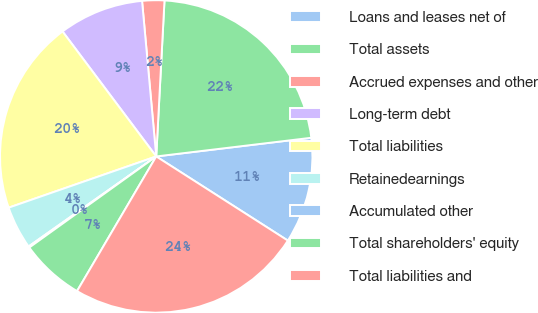Convert chart. <chart><loc_0><loc_0><loc_500><loc_500><pie_chart><fcel>Loans and leases net of<fcel>Total assets<fcel>Accrued expenses and other<fcel>Long-term debt<fcel>Total liabilities<fcel>Retainedearnings<fcel>Accumulated other<fcel>Total shareholders' equity<fcel>Total liabilities and<nl><fcel>10.96%<fcel>22.25%<fcel>2.29%<fcel>8.79%<fcel>20.08%<fcel>4.46%<fcel>0.13%<fcel>6.63%<fcel>24.41%<nl></chart> 